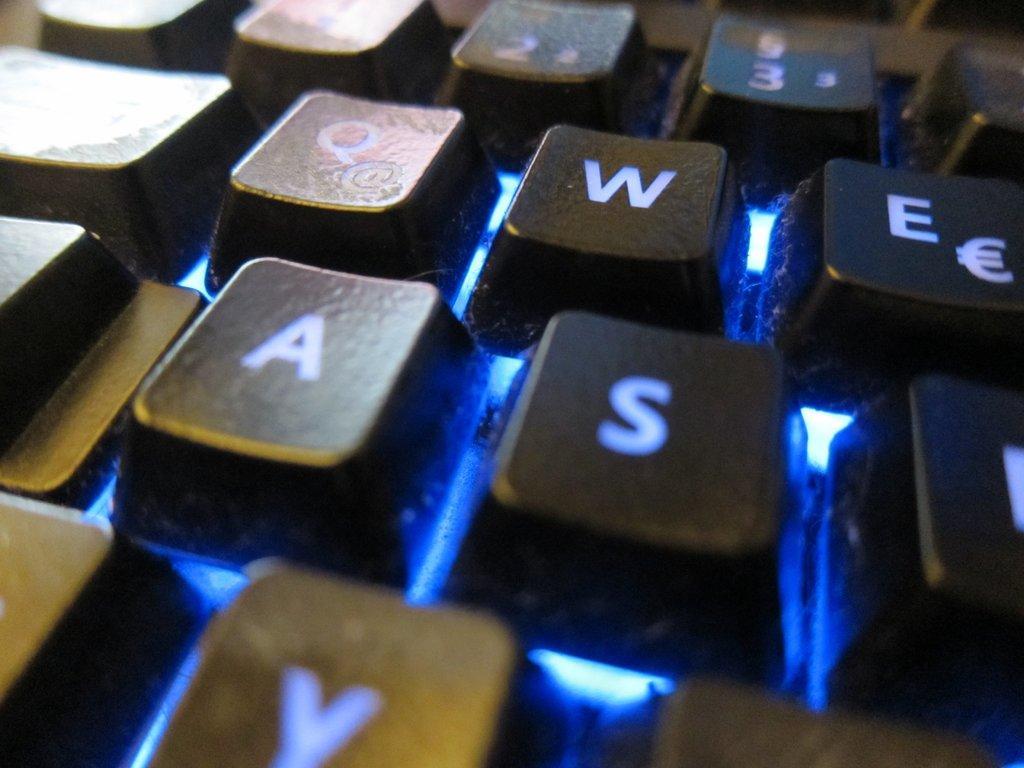Describe this image in one or two sentences. In this image I can see few black color keyboard keys. I can see the blue color light. 